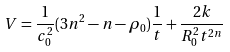Convert formula to latex. <formula><loc_0><loc_0><loc_500><loc_500>V = \frac { 1 } { c _ { 0 } ^ { 2 } } ( 3 n ^ { 2 } - n - \rho _ { 0 } ) \frac { 1 } { t } + \frac { 2 k } { R _ { 0 } ^ { 2 } t ^ { 2 n } }</formula> 